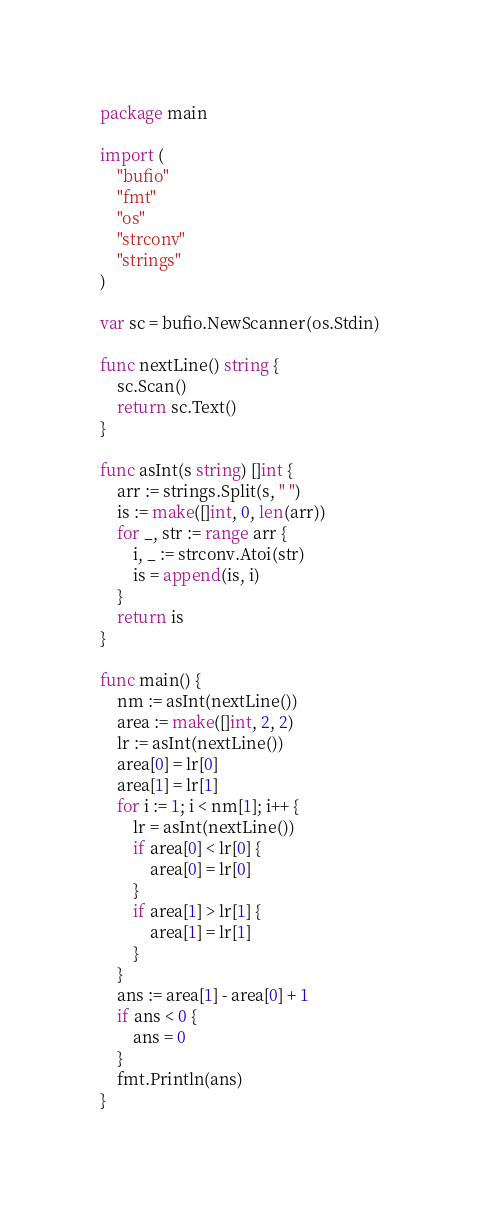<code> <loc_0><loc_0><loc_500><loc_500><_Go_>package main

import (
	"bufio"
	"fmt"
	"os"
	"strconv"
	"strings"
)

var sc = bufio.NewScanner(os.Stdin)

func nextLine() string {
	sc.Scan()
	return sc.Text()
}

func asInt(s string) []int {
	arr := strings.Split(s, " ")
	is := make([]int, 0, len(arr))
	for _, str := range arr {
		i, _ := strconv.Atoi(str)
		is = append(is, i)
	}
	return is
}

func main() {
	nm := asInt(nextLine())
	area := make([]int, 2, 2)
	lr := asInt(nextLine())
	area[0] = lr[0]
	area[1] = lr[1]
	for i := 1; i < nm[1]; i++ {
		lr = asInt(nextLine())
		if area[0] < lr[0] {
			area[0] = lr[0]
		}
		if area[1] > lr[1] {
			area[1] = lr[1]
		}
	}
	ans := area[1] - area[0] + 1
	if ans < 0 {
		ans = 0
	}
	fmt.Println(ans)
}
</code> 